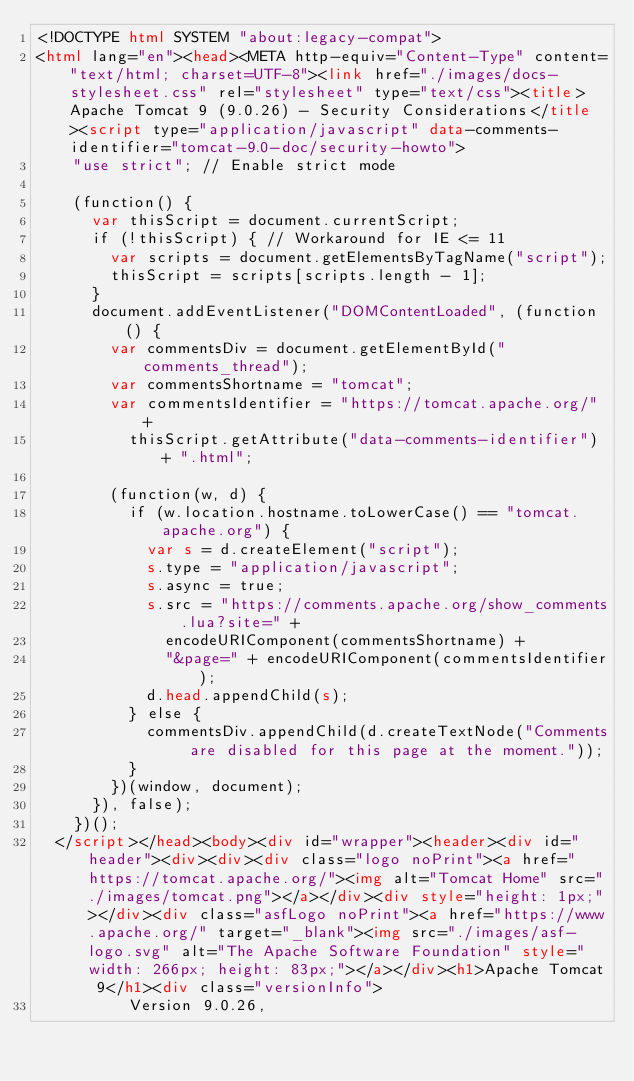<code> <loc_0><loc_0><loc_500><loc_500><_HTML_><!DOCTYPE html SYSTEM "about:legacy-compat">
<html lang="en"><head><META http-equiv="Content-Type" content="text/html; charset=UTF-8"><link href="./images/docs-stylesheet.css" rel="stylesheet" type="text/css"><title>Apache Tomcat 9 (9.0.26) - Security Considerations</title><script type="application/javascript" data-comments-identifier="tomcat-9.0-doc/security-howto">
    "use strict"; // Enable strict mode

    (function() {
      var thisScript = document.currentScript;
      if (!thisScript) { // Workaround for IE <= 11
        var scripts = document.getElementsByTagName("script");
        thisScript = scripts[scripts.length - 1];
      }
      document.addEventListener("DOMContentLoaded", (function() {
        var commentsDiv = document.getElementById("comments_thread");
        var commentsShortname = "tomcat";
        var commentsIdentifier = "https://tomcat.apache.org/" +
          thisScript.getAttribute("data-comments-identifier") + ".html";

        (function(w, d) {
          if (w.location.hostname.toLowerCase() == "tomcat.apache.org") {
            var s = d.createElement("script");
            s.type = "application/javascript";
            s.async = true;
            s.src = "https://comments.apache.org/show_comments.lua?site=" +
              encodeURIComponent(commentsShortname) +
              "&page=" + encodeURIComponent(commentsIdentifier);
            d.head.appendChild(s);
          } else {
            commentsDiv.appendChild(d.createTextNode("Comments are disabled for this page at the moment."));
          }
        })(window, document);
      }), false);
    })();
  </script></head><body><div id="wrapper"><header><div id="header"><div><div><div class="logo noPrint"><a href="https://tomcat.apache.org/"><img alt="Tomcat Home" src="./images/tomcat.png"></a></div><div style="height: 1px;"></div><div class="asfLogo noPrint"><a href="https://www.apache.org/" target="_blank"><img src="./images/asf-logo.svg" alt="The Apache Software Foundation" style="width: 266px; height: 83px;"></a></div><h1>Apache Tomcat 9</h1><div class="versionInfo">
          Version 9.0.26,</code> 